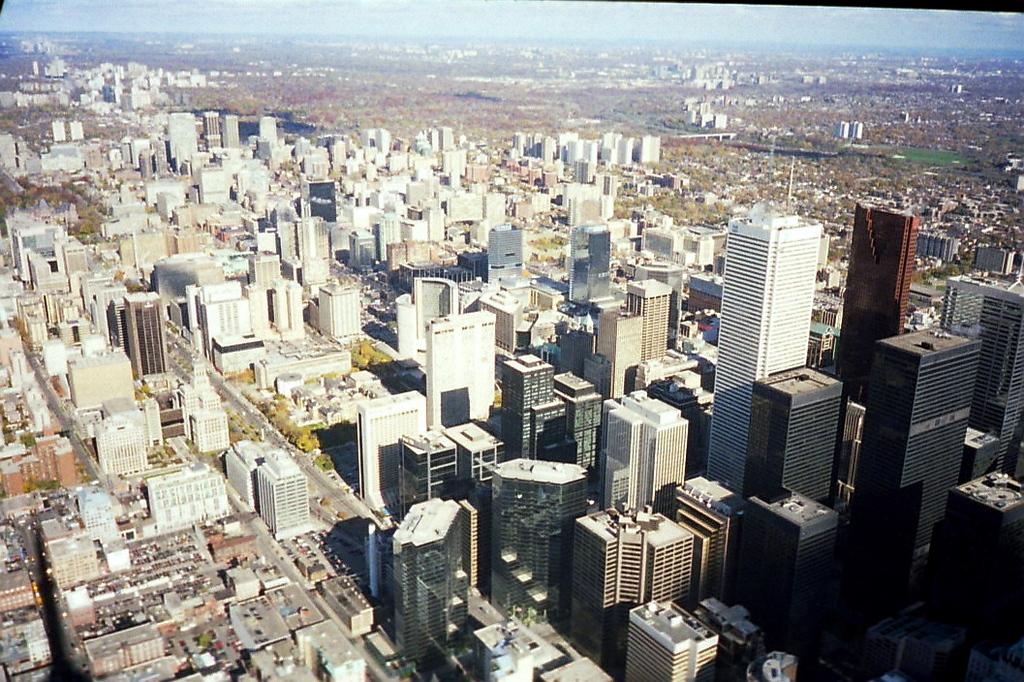What type of view is shown in the image? The image is an aerial view. What structures can be seen in the image? There are buildings and skyscrapers in the image. What natural elements are present in the image? There are trees in the image. What type of transportation is visible on the road in the image? Motor vehicles are visible on the road in the image. What type of brush is used to paint the winter scene in the image? There is no winter scene or brush present in the image; it is an aerial view of a cityscape. Can you see any footprints in the snow in the image? There is no snow or footprints present in the image; it is an aerial view of a cityscape with buildings, skyscrapers, trees, and motor vehicles. 